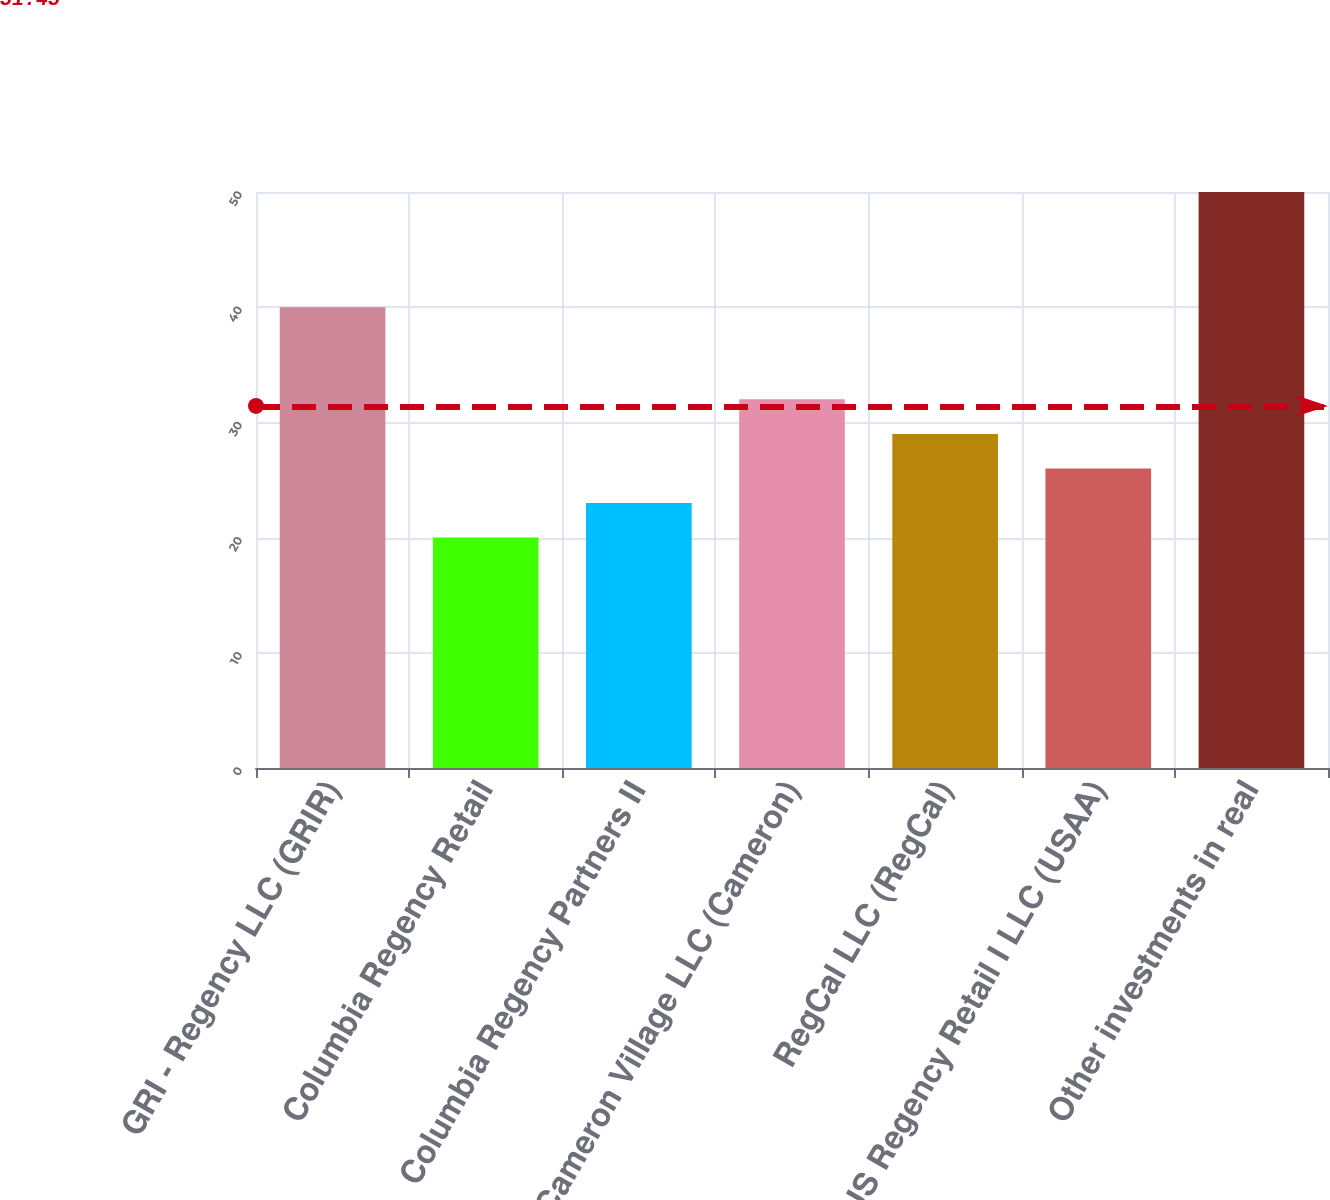<chart> <loc_0><loc_0><loc_500><loc_500><bar_chart><fcel>GRI - Regency LLC (GRIR)<fcel>Columbia Regency Retail<fcel>Columbia Regency Partners II<fcel>Cameron Village LLC (Cameron)<fcel>RegCal LLC (RegCal)<fcel>US Regency Retail I LLC (USAA)<fcel>Other investments in real<nl><fcel>40<fcel>20<fcel>23<fcel>32<fcel>29<fcel>26<fcel>50<nl></chart> 